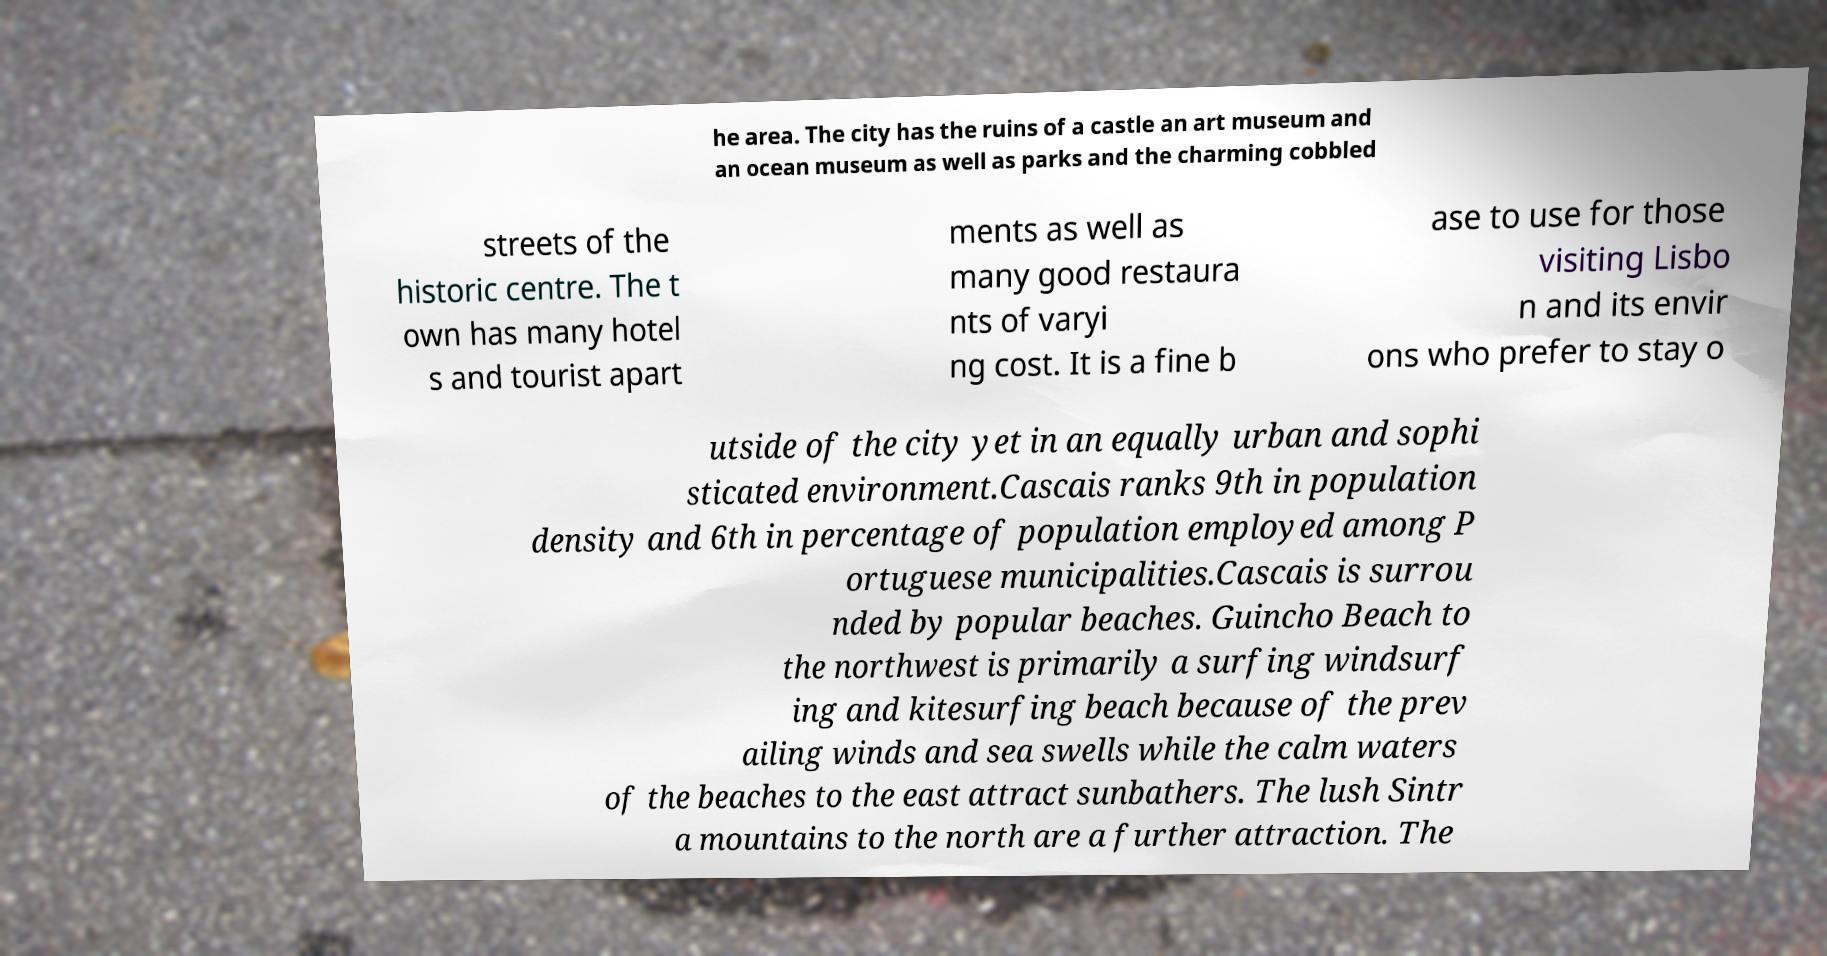Could you extract and type out the text from this image? he area. The city has the ruins of a castle an art museum and an ocean museum as well as parks and the charming cobbled streets of the historic centre. The t own has many hotel s and tourist apart ments as well as many good restaura nts of varyi ng cost. It is a fine b ase to use for those visiting Lisbo n and its envir ons who prefer to stay o utside of the city yet in an equally urban and sophi sticated environment.Cascais ranks 9th in population density and 6th in percentage of population employed among P ortuguese municipalities.Cascais is surrou nded by popular beaches. Guincho Beach to the northwest is primarily a surfing windsurf ing and kitesurfing beach because of the prev ailing winds and sea swells while the calm waters of the beaches to the east attract sunbathers. The lush Sintr a mountains to the north are a further attraction. The 